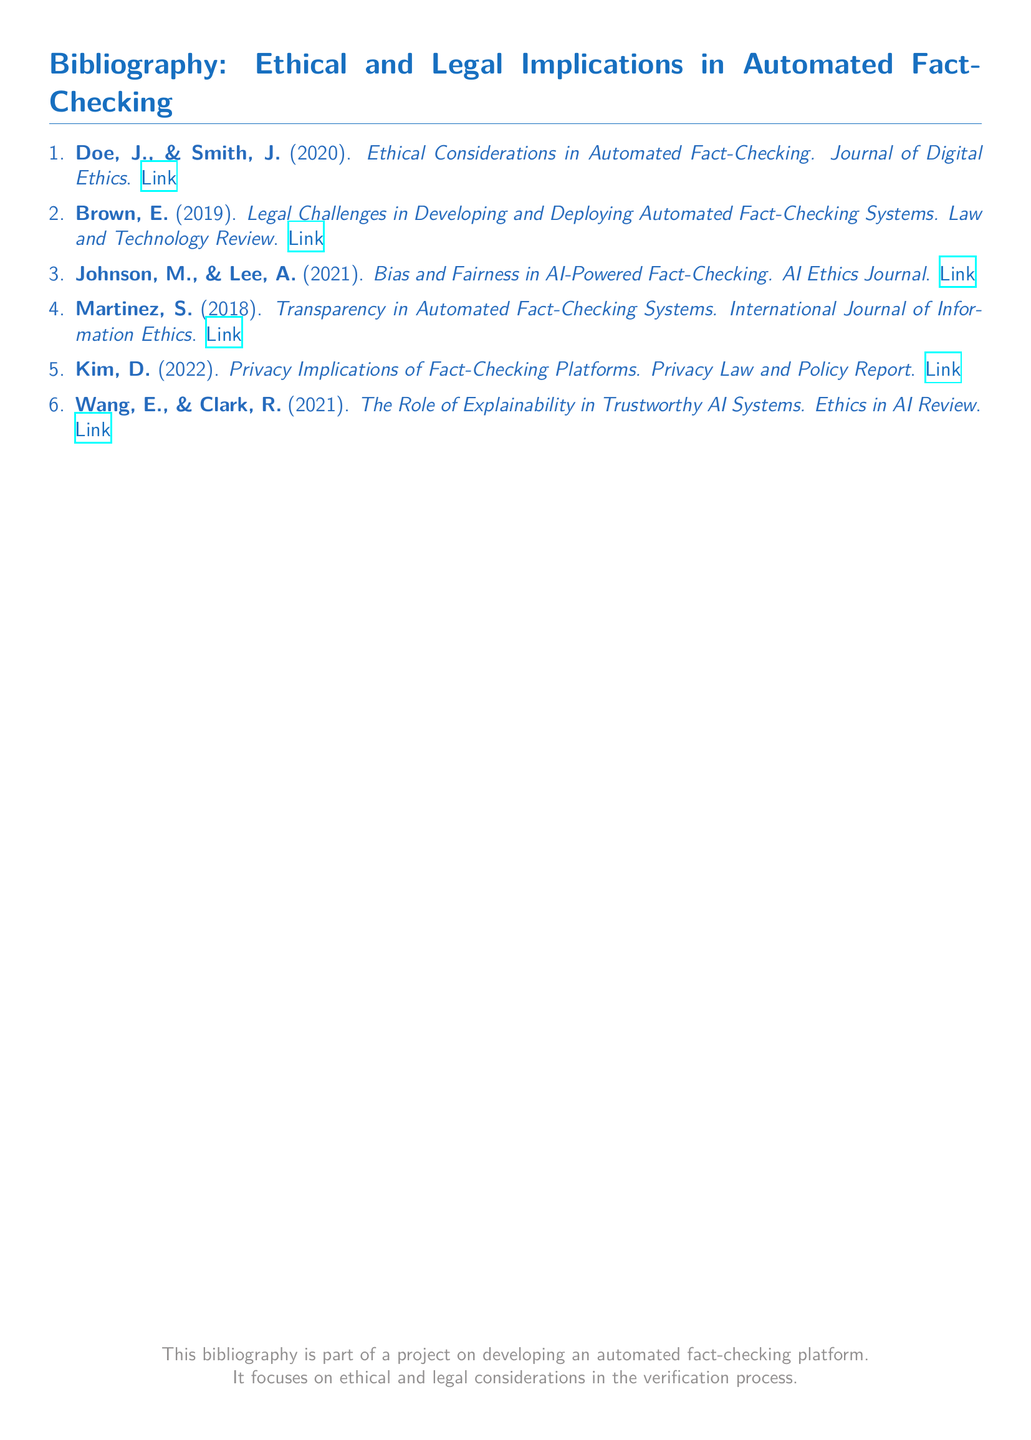What is the title of the first entry? The title of the first entry listed in the bibliography is about "Ethical Considerations in Automated Fact-Checking."
Answer: Ethical Considerations in Automated Fact-Checking Who are the authors of the second entry? The authors of the second entry are Brown and E.
Answer: Brown, E In what year was the paper about bias and fairness published? The paper discussing bias and fairness in AI-Powered Fact-Checking was published in 2021.
Answer: 2021 What journal published the paper on transparency? The paper on transparency was published in the "International Journal of Information Ethics."
Answer: International Journal of Information Ethics What is the main focus of the bibliography? The main focus of the bibliography is on ethical and legal implications in automated fact-checking systems.
Answer: Ethical and legal implications How many entries are listed under the bibliography? There are six entries listed under the bibliography.
Answer: 6 Which entry discusses privacy implications? The entry that discusses privacy implications is authored by Kim.
Answer: Kim, D What is the publication year of the last cited work? The last cited work was published in 2021.
Answer: 2021 